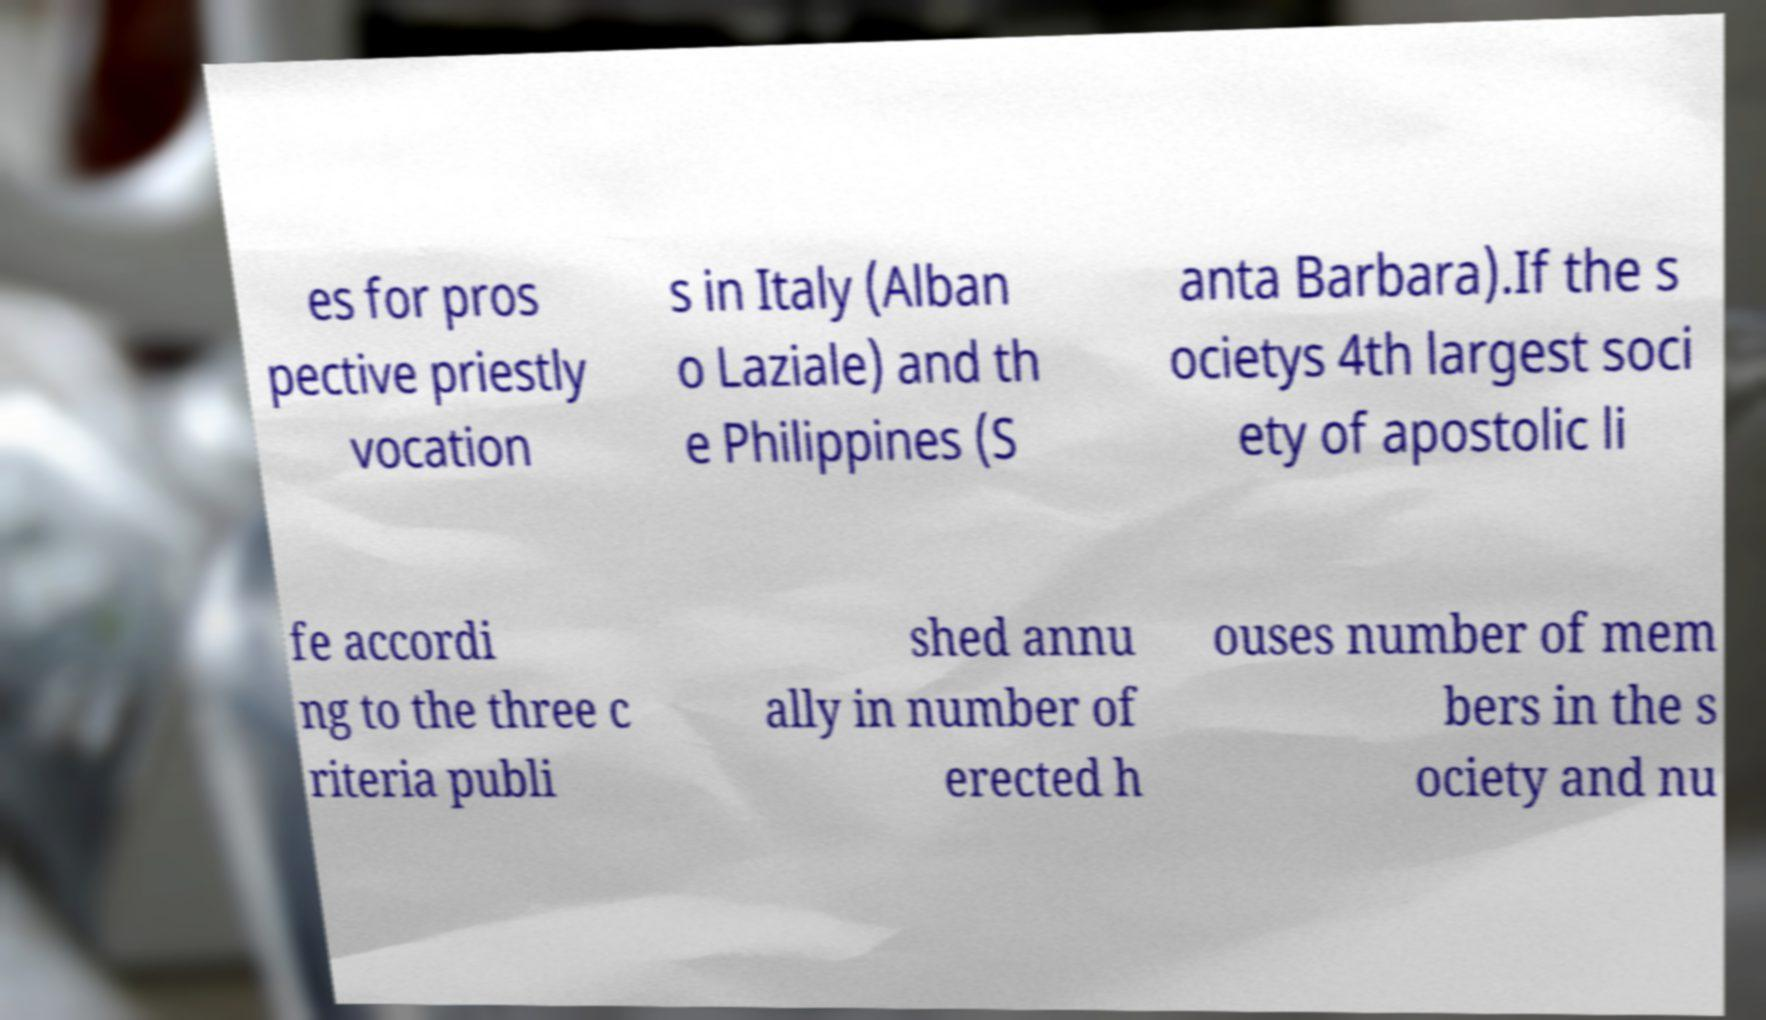What messages or text are displayed in this image? I need them in a readable, typed format. es for pros pective priestly vocation s in Italy (Alban o Laziale) and th e Philippines (S anta Barbara).If the s ocietys 4th largest soci ety of apostolic li fe accordi ng to the three c riteria publi shed annu ally in number of erected h ouses number of mem bers in the s ociety and nu 